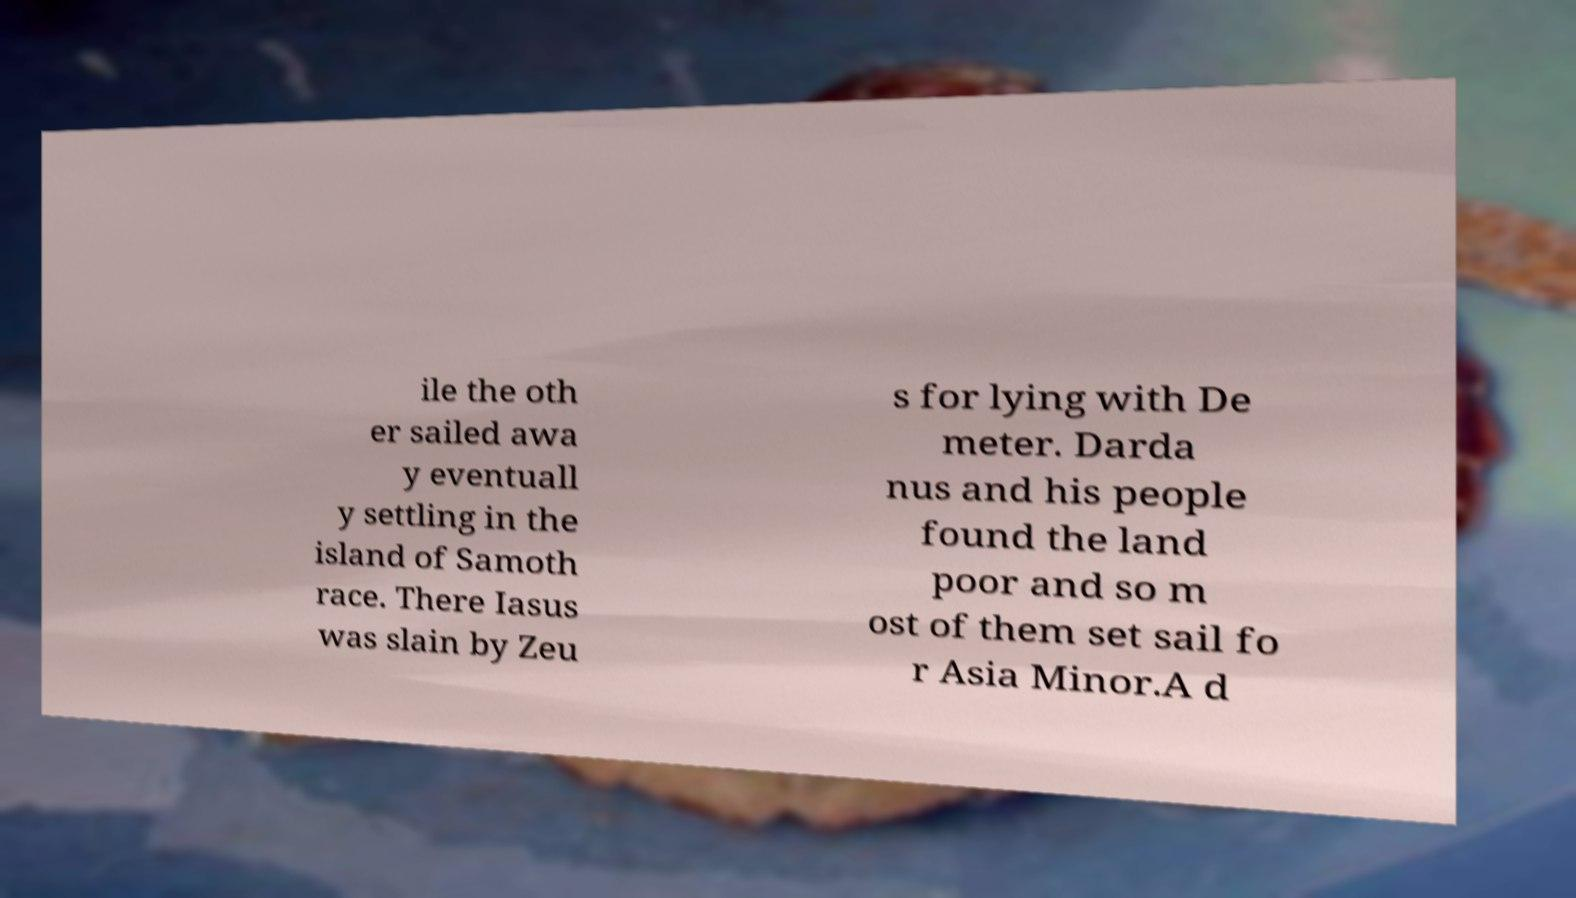For documentation purposes, I need the text within this image transcribed. Could you provide that? ile the oth er sailed awa y eventuall y settling in the island of Samoth race. There Iasus was slain by Zeu s for lying with De meter. Darda nus and his people found the land poor and so m ost of them set sail fo r Asia Minor.A d 